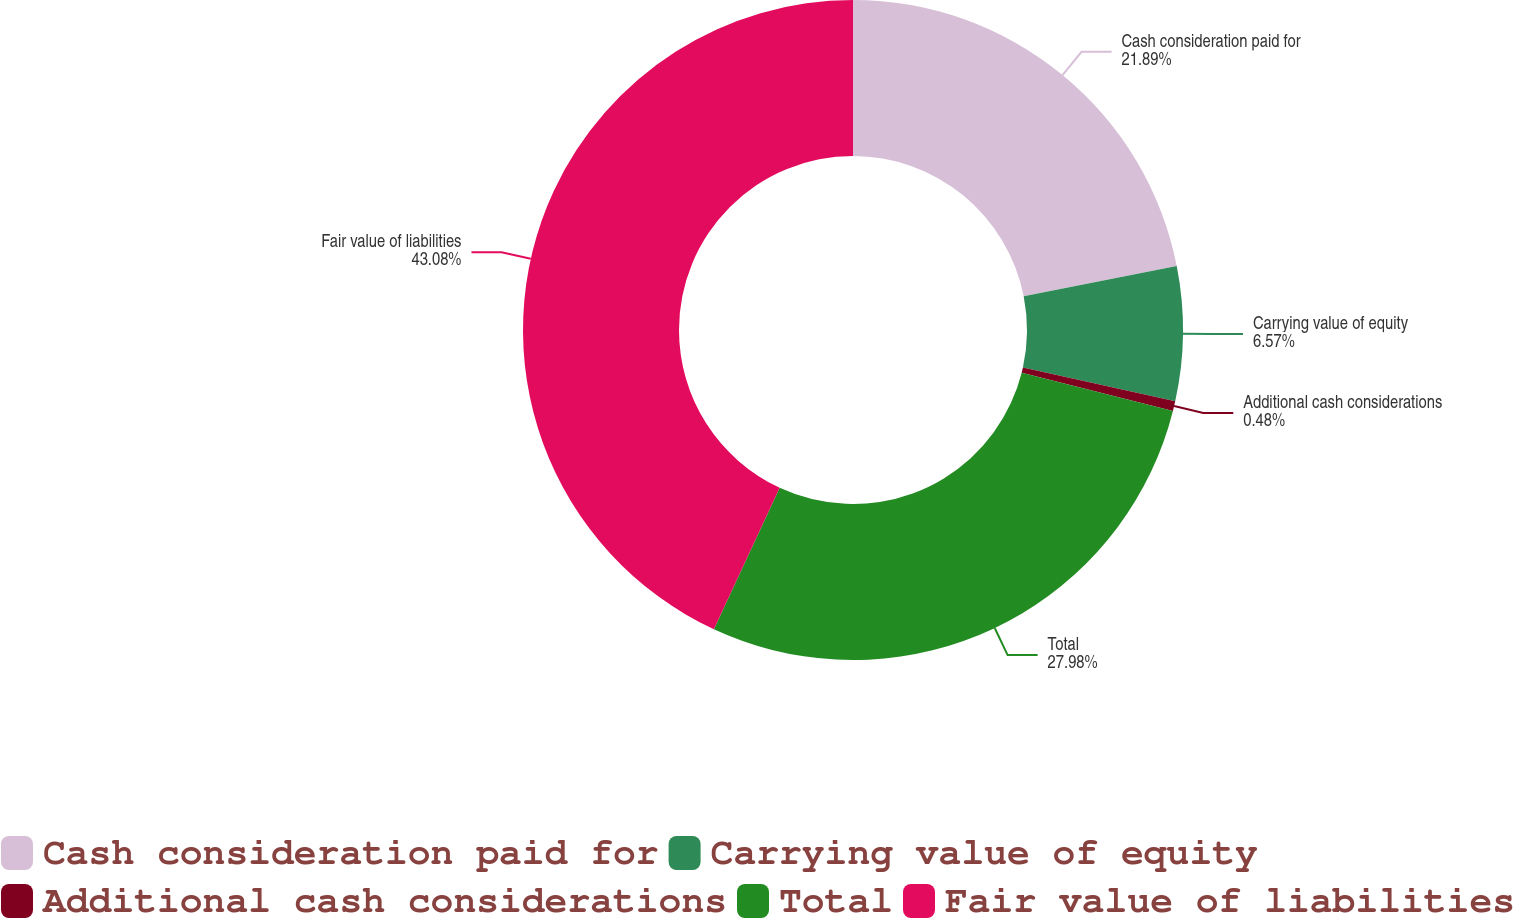Convert chart. <chart><loc_0><loc_0><loc_500><loc_500><pie_chart><fcel>Cash consideration paid for<fcel>Carrying value of equity<fcel>Additional cash considerations<fcel>Total<fcel>Fair value of liabilities<nl><fcel>21.89%<fcel>6.57%<fcel>0.48%<fcel>27.98%<fcel>43.07%<nl></chart> 